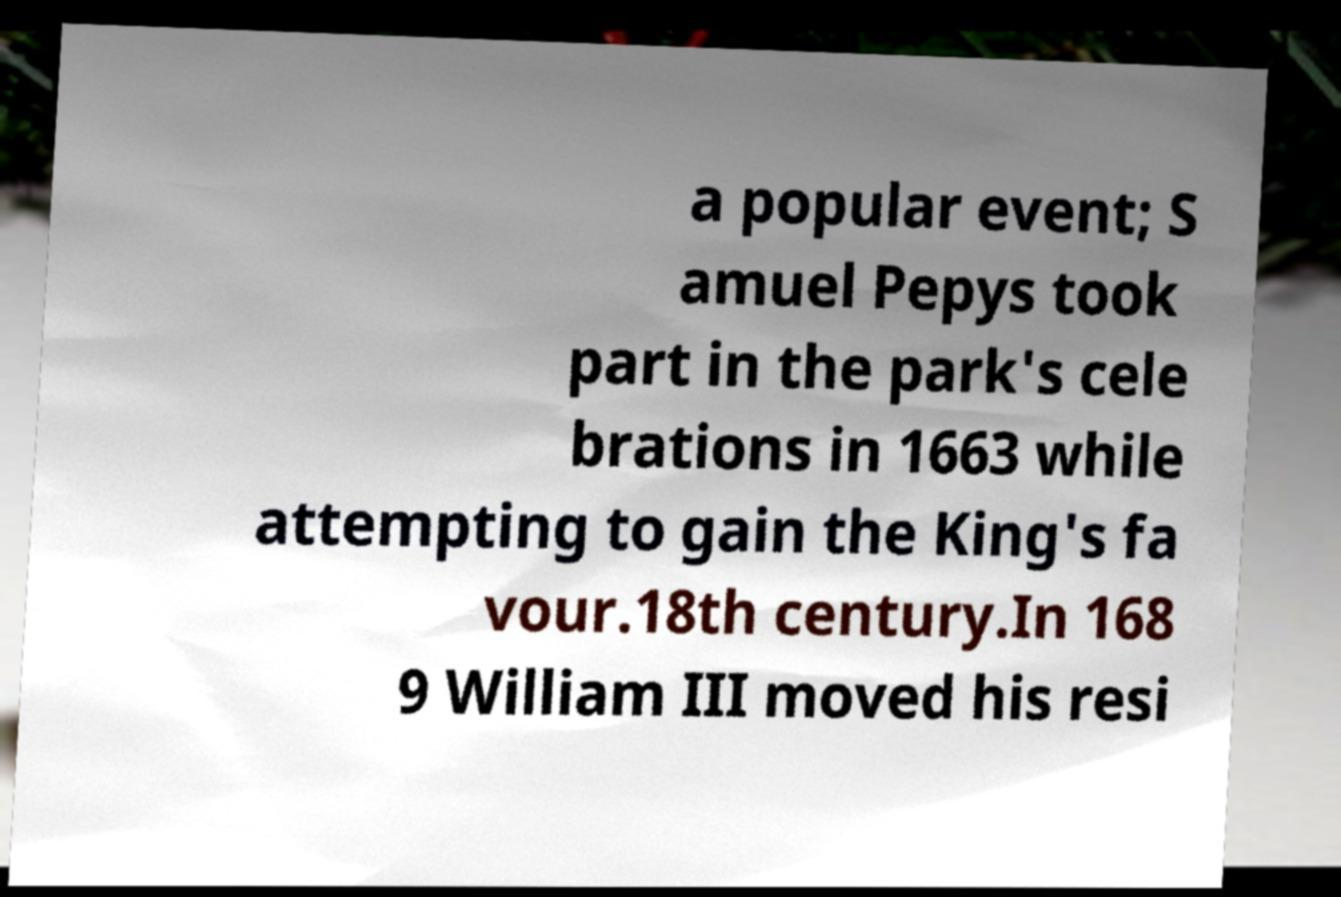There's text embedded in this image that I need extracted. Can you transcribe it verbatim? a popular event; S amuel Pepys took part in the park's cele brations in 1663 while attempting to gain the King's fa vour.18th century.In 168 9 William III moved his resi 